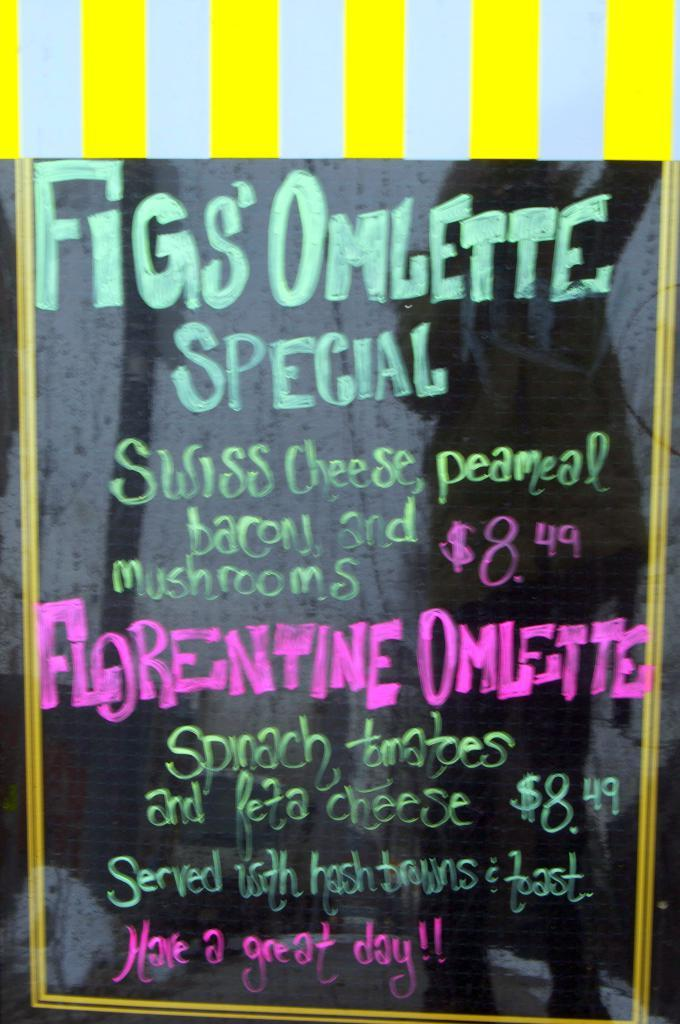Provide a one-sentence caption for the provided image. Chalk on blackboard sign announcing Fig's Omlette Special in sea foam green. 